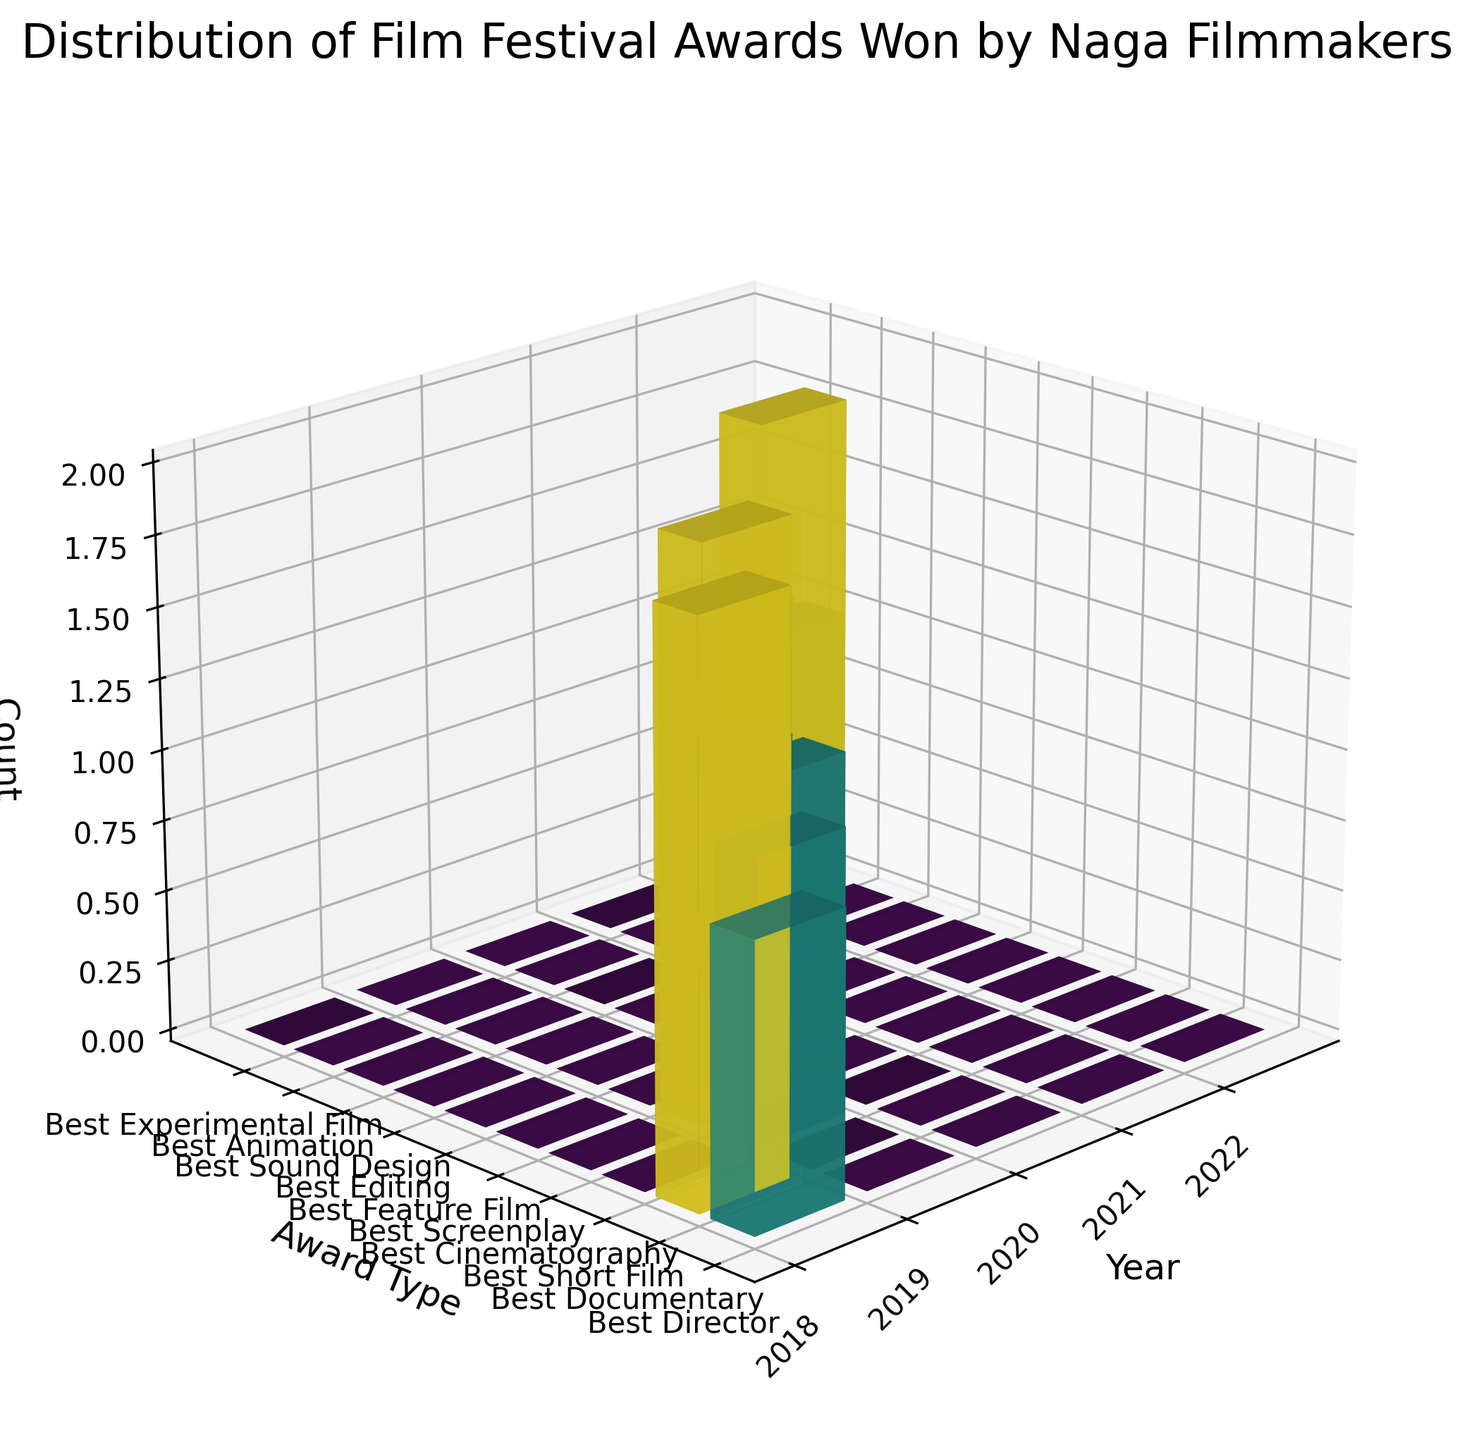What's the title of the figure? The title is displayed at the top of the figure. It reads "Distribution of Film Festival Awards Won by Naga Filmmakers".
Answer: Distribution of Film Festival Awards Won by Naga Filmmakers Which year saw the most awards won by Naga filmmakers? By observing the height of the bars along the year axis, the year with the highest total count of awards is 2021, as it has the tallest bars in total compared to other years.
Answer: 2021 How many awards were won in total in 2020? In 2020, there are two bars representing awards: Best Screenplay and Best Feature Film. Both bars have heights of 1. Adding them gives a total of 1 + 1 = 2 awards.
Answer: 2 Which award type had the highest count in any given year, and what was the count? The award type "Best Documentary" in 2018 had the highest count of any award type in a given year with a count of 2.
Answer: Best Documentary, 2 How many times did Theja Rio win an award, judging by both award types and years? Theja Rio won awards in two different categories over two years: Best Cinematography in 2019 and Best Sound Design in 2021. The bar heights for both awards are 2 and 1 respectively, so the total is 2 + 1 = 3.
Answer: 3 How does the number of awards won in 2021 compare to 2018? In 2021, there are two bars with counts of 2 and 1, totalizing 2 + 1 = 3 awards. In 2018, there are two bars with counts of 1 and 2, totalizing 1 + 2 = 3 awards. Both years have the same total count of awards.
Answer: Same What is the total count of awards won across all years? Adding the counts of all the bars: 1 (2018) + 2 (2018) + 1 (2019) + 2 (2019) + 1 (2020) + 1 (2020) + 2 (2021) + 1 (2021) + 1 (2022) + 1 (2022) = 13.
Answer: 13 